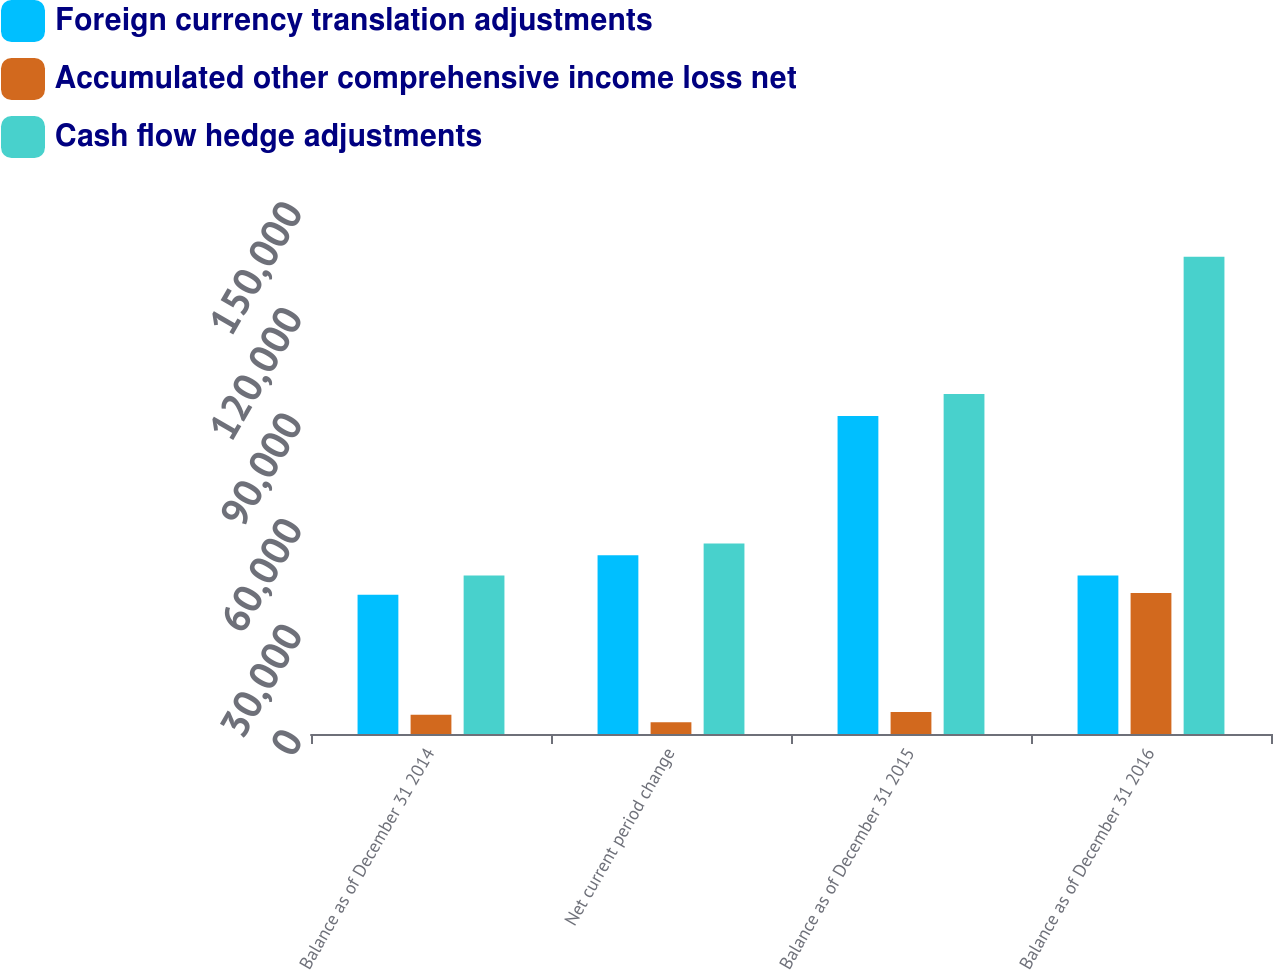Convert chart. <chart><loc_0><loc_0><loc_500><loc_500><stacked_bar_chart><ecel><fcel>Balance as of December 31 2014<fcel>Net current period change<fcel>Balance as of December 31 2015<fcel>Balance as of December 31 2016<nl><fcel>Foreign currency translation adjustments<fcel>39567<fcel>50775<fcel>90342<fcel>45046<nl><fcel>Accumulated other comprehensive income loss net<fcel>5479<fcel>3338<fcel>6248<fcel>40037<nl><fcel>Cash flow hedge adjustments<fcel>45046<fcel>54113<fcel>96590<fcel>135605<nl></chart> 